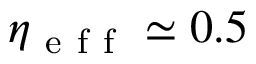Convert formula to latex. <formula><loc_0><loc_0><loc_500><loc_500>\eta _ { e f f } \simeq 0 . 5</formula> 